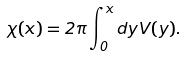<formula> <loc_0><loc_0><loc_500><loc_500>\chi ( x ) = 2 \pi \int _ { 0 } ^ { x } d y V ( y ) .</formula> 